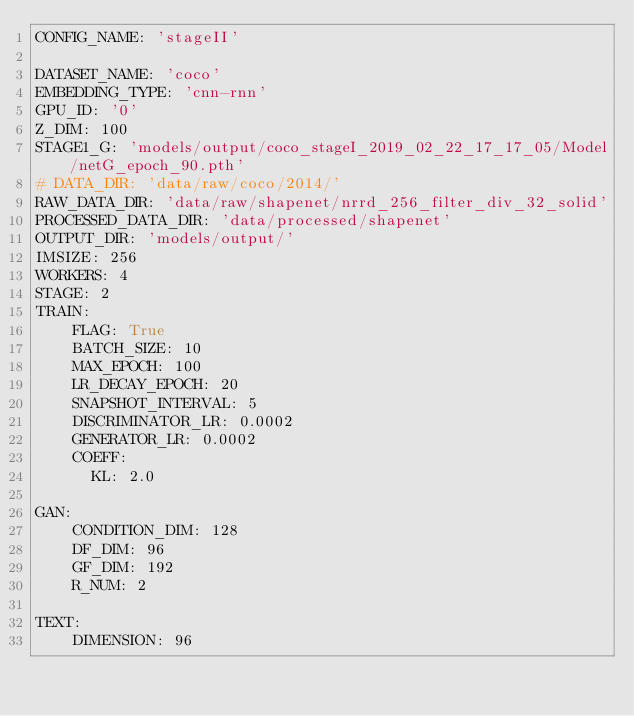<code> <loc_0><loc_0><loc_500><loc_500><_YAML_>CONFIG_NAME: 'stageII'

DATASET_NAME: 'coco'
EMBEDDING_TYPE: 'cnn-rnn'
GPU_ID: '0'
Z_DIM: 100
STAGE1_G: 'models/output/coco_stageI_2019_02_22_17_17_05/Model/netG_epoch_90.pth'
# DATA_DIR: 'data/raw/coco/2014/'
RAW_DATA_DIR: 'data/raw/shapenet/nrrd_256_filter_div_32_solid'
PROCESSED_DATA_DIR: 'data/processed/shapenet'
OUTPUT_DIR: 'models/output/'
IMSIZE: 256
WORKERS: 4
STAGE: 2
TRAIN:
    FLAG: True
    BATCH_SIZE: 10
    MAX_EPOCH: 100
    LR_DECAY_EPOCH: 20
    SNAPSHOT_INTERVAL: 5
    DISCRIMINATOR_LR: 0.0002
    GENERATOR_LR: 0.0002
    COEFF:
      KL: 2.0

GAN:
    CONDITION_DIM: 128
    DF_DIM: 96
    GF_DIM: 192
    R_NUM: 2

TEXT:
    DIMENSION: 96
</code> 